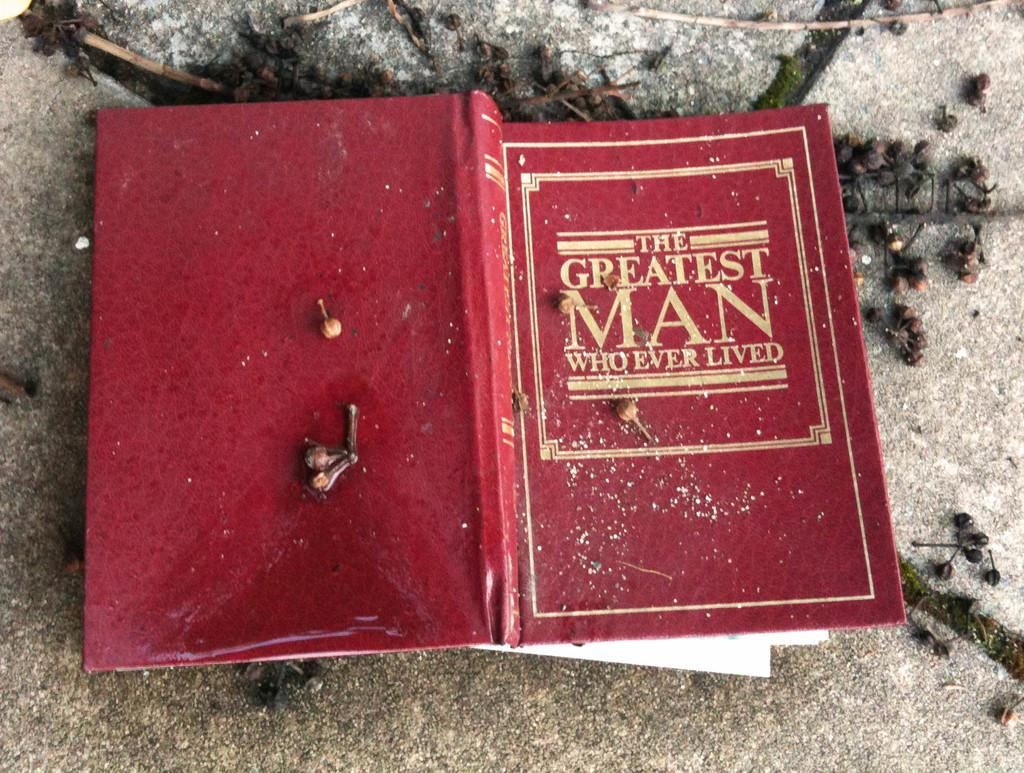<image>
Share a concise interpretation of the image provided. A book is open with the title The Greatest Man Who Ever Lived showing on a red background. 